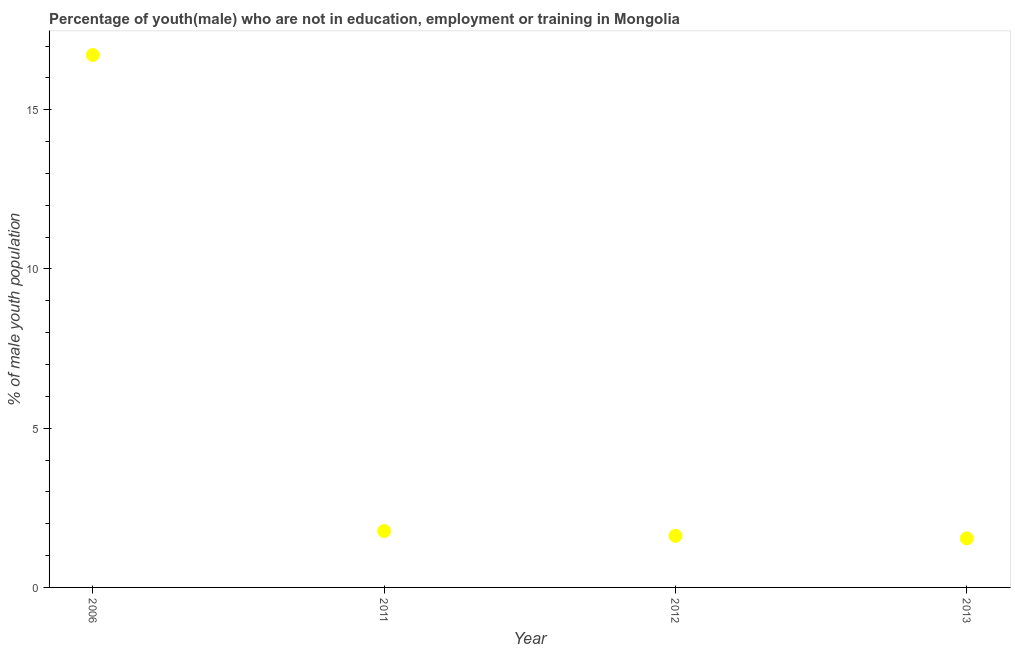What is the unemployed male youth population in 2011?
Your answer should be compact. 1.77. Across all years, what is the maximum unemployed male youth population?
Offer a terse response. 16.72. Across all years, what is the minimum unemployed male youth population?
Make the answer very short. 1.54. In which year was the unemployed male youth population minimum?
Offer a very short reply. 2013. What is the sum of the unemployed male youth population?
Offer a terse response. 21.65. What is the difference between the unemployed male youth population in 2006 and 2012?
Your response must be concise. 15.1. What is the average unemployed male youth population per year?
Make the answer very short. 5.41. What is the median unemployed male youth population?
Keep it short and to the point. 1.69. In how many years, is the unemployed male youth population greater than 7 %?
Your response must be concise. 1. What is the ratio of the unemployed male youth population in 2011 to that in 2013?
Provide a succinct answer. 1.15. Is the unemployed male youth population in 2012 less than that in 2013?
Your answer should be compact. No. Is the difference between the unemployed male youth population in 2011 and 2013 greater than the difference between any two years?
Give a very brief answer. No. What is the difference between the highest and the second highest unemployed male youth population?
Offer a very short reply. 14.95. Is the sum of the unemployed male youth population in 2006 and 2013 greater than the maximum unemployed male youth population across all years?
Give a very brief answer. Yes. What is the difference between the highest and the lowest unemployed male youth population?
Provide a succinct answer. 15.18. What is the difference between two consecutive major ticks on the Y-axis?
Your answer should be very brief. 5. Are the values on the major ticks of Y-axis written in scientific E-notation?
Provide a short and direct response. No. Does the graph contain any zero values?
Your response must be concise. No. Does the graph contain grids?
Offer a terse response. No. What is the title of the graph?
Give a very brief answer. Percentage of youth(male) who are not in education, employment or training in Mongolia. What is the label or title of the Y-axis?
Make the answer very short. % of male youth population. What is the % of male youth population in 2006?
Your answer should be very brief. 16.72. What is the % of male youth population in 2011?
Your answer should be compact. 1.77. What is the % of male youth population in 2012?
Your response must be concise. 1.62. What is the % of male youth population in 2013?
Give a very brief answer. 1.54. What is the difference between the % of male youth population in 2006 and 2011?
Make the answer very short. 14.95. What is the difference between the % of male youth population in 2006 and 2013?
Offer a terse response. 15.18. What is the difference between the % of male youth population in 2011 and 2012?
Provide a short and direct response. 0.15. What is the difference between the % of male youth population in 2011 and 2013?
Your response must be concise. 0.23. What is the ratio of the % of male youth population in 2006 to that in 2011?
Provide a short and direct response. 9.45. What is the ratio of the % of male youth population in 2006 to that in 2012?
Provide a short and direct response. 10.32. What is the ratio of the % of male youth population in 2006 to that in 2013?
Your answer should be very brief. 10.86. What is the ratio of the % of male youth population in 2011 to that in 2012?
Offer a very short reply. 1.09. What is the ratio of the % of male youth population in 2011 to that in 2013?
Your answer should be compact. 1.15. What is the ratio of the % of male youth population in 2012 to that in 2013?
Your answer should be very brief. 1.05. 